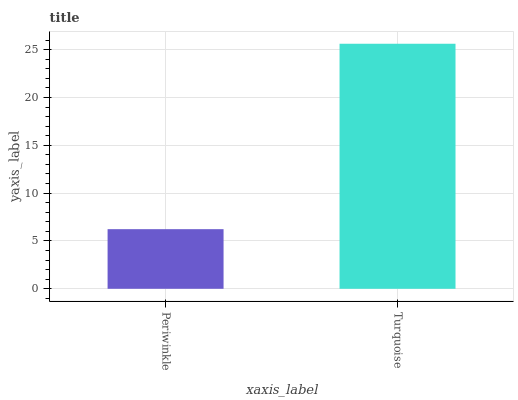Is Turquoise the minimum?
Answer yes or no. No. Is Turquoise greater than Periwinkle?
Answer yes or no. Yes. Is Periwinkle less than Turquoise?
Answer yes or no. Yes. Is Periwinkle greater than Turquoise?
Answer yes or no. No. Is Turquoise less than Periwinkle?
Answer yes or no. No. Is Turquoise the high median?
Answer yes or no. Yes. Is Periwinkle the low median?
Answer yes or no. Yes. Is Periwinkle the high median?
Answer yes or no. No. Is Turquoise the low median?
Answer yes or no. No. 